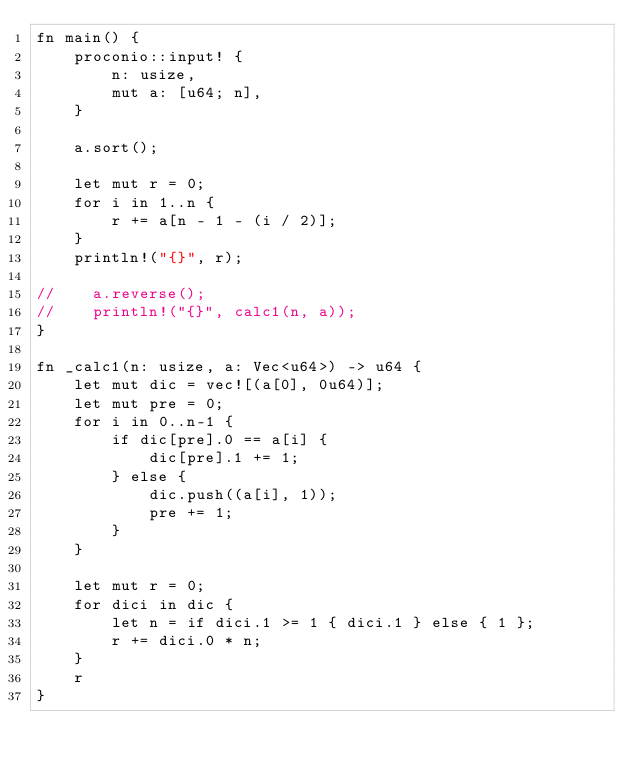Convert code to text. <code><loc_0><loc_0><loc_500><loc_500><_Rust_>fn main() {
    proconio::input! {
        n: usize,
        mut a: [u64; n],
    }

    a.sort();

    let mut r = 0;
    for i in 1..n {
        r += a[n - 1 - (i / 2)];
    }
    println!("{}", r);

//    a.reverse();
//    println!("{}", calc1(n, a));
}

fn _calc1(n: usize, a: Vec<u64>) -> u64 {
    let mut dic = vec![(a[0], 0u64)];
    let mut pre = 0;
    for i in 0..n-1 {
        if dic[pre].0 == a[i] {
            dic[pre].1 += 1;
        } else {
            dic.push((a[i], 1));
            pre += 1;
        }
    }

    let mut r = 0;
    for dici in dic {
        let n = if dici.1 >= 1 { dici.1 } else { 1 };
        r += dici.0 * n;
    }
    r
}
</code> 